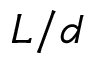<formula> <loc_0><loc_0><loc_500><loc_500>L / d</formula> 